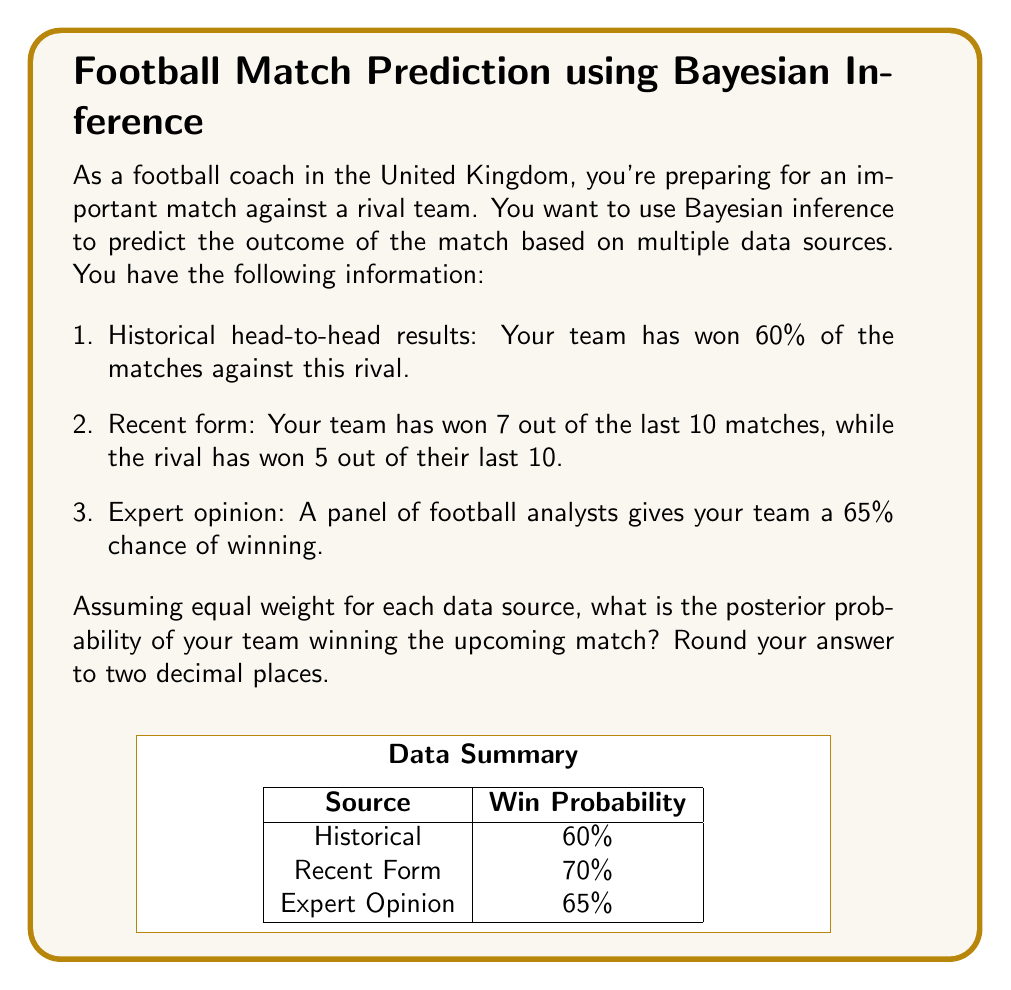Help me with this question. To solve this problem using Bayesian inference, we'll follow these steps:

1. Define our prior probability based on the historical head-to-head results.
2. Update our belief using the recent form data.
3. Further update our belief using the expert opinion.
4. Calculate the final posterior probability.

Step 1: Prior probability
The historical head-to-head results give us a prior probability of winning:
$P(win) = 0.60$

Step 2: Update with recent form
We'll use Bayes' theorem to update our belief:

$$P(win|recent\_form) = \frac{P(recent\_form|win) \cdot P(win)}{P(recent\_form)}$$

$P(recent\_form|win) = 0.7$ (7 out of 10 matches won)
$P(win) = 0.60$ (our prior)
$P(recent\_form) = 0.7 \cdot 0.60 + 0.5 \cdot 0.40 = 0.62$ (total probability)

$$P(win|recent\_form) = \frac{0.7 \cdot 0.60}{0.62} \approx 0.6774$$

Step 3: Update with expert opinion
We'll use Bayes' theorem again:

$$P(win|expert) = \frac{P(expert|win) \cdot P(win|recent\_form)}{P(expert)}$$

$P(expert|win) = 0.65$ (expert opinion)
$P(win|recent\_form) = 0.6774$ (from step 2)
$P(expert) = 0.65 \cdot 0.6774 + 0.35 \cdot 0.3226 = 0.65$ (total probability)

$$P(win|expert) = \frac{0.65 \cdot 0.6774}{0.65} \approx 0.6774$$

Step 4: Calculate final posterior probability
Since we're assuming equal weight for each data source, we'll take the average of our three probabilities:

$$P(win|all\_data) = \frac{0.60 + 0.6774 + 0.6774}{3} \approx 0.6516$$

Rounding to two decimal places, we get 0.65.
Answer: 0.65 